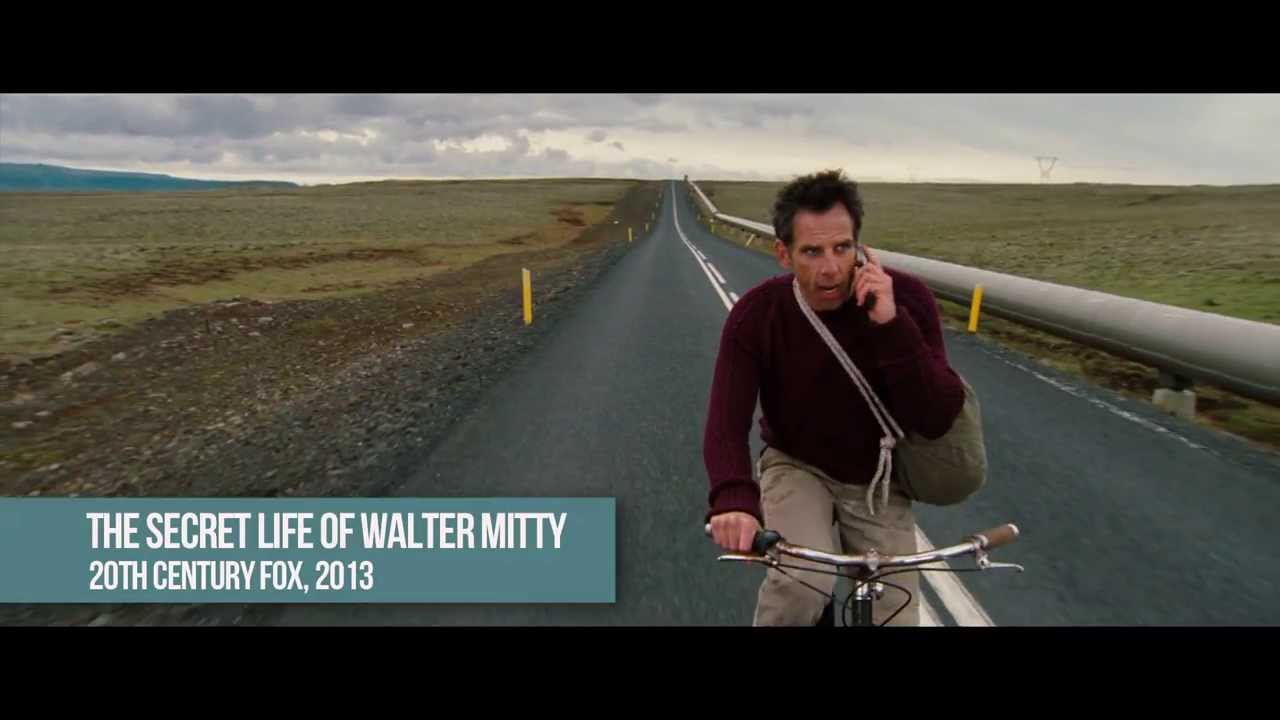How does the weather impact the visual mood of this setting? The overcast sky introduces a somber and subdued mood, muting the colors of the landscape and giving the scene a monochrome appearance, which could reflect the internal state of the figure, possibly his thoughts or emotions. What does the choice of clothing suggest about the figure in the image? The maroon sweater and casual attire suggest a personal, informal endeavor rather than a professional or formal occasion. This choice might indicate the man's need for comfort and functionality, aligning with the nature of a solitary ride in an expansive setting. 